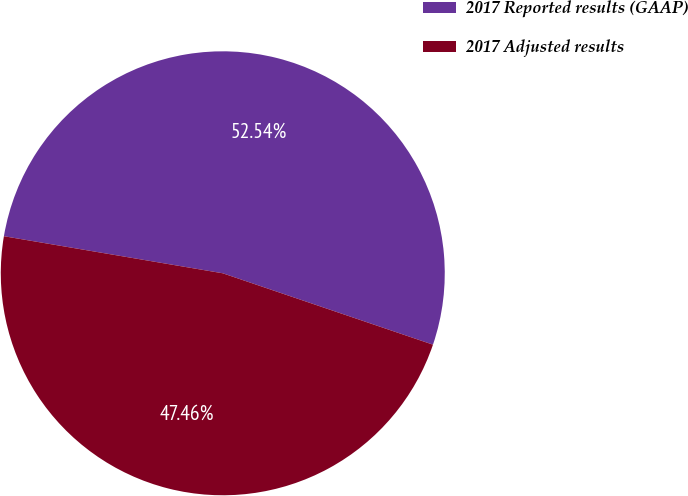Convert chart. <chart><loc_0><loc_0><loc_500><loc_500><pie_chart><fcel>2017 Reported results (GAAP)<fcel>2017 Adjusted results<nl><fcel>52.54%<fcel>47.46%<nl></chart> 